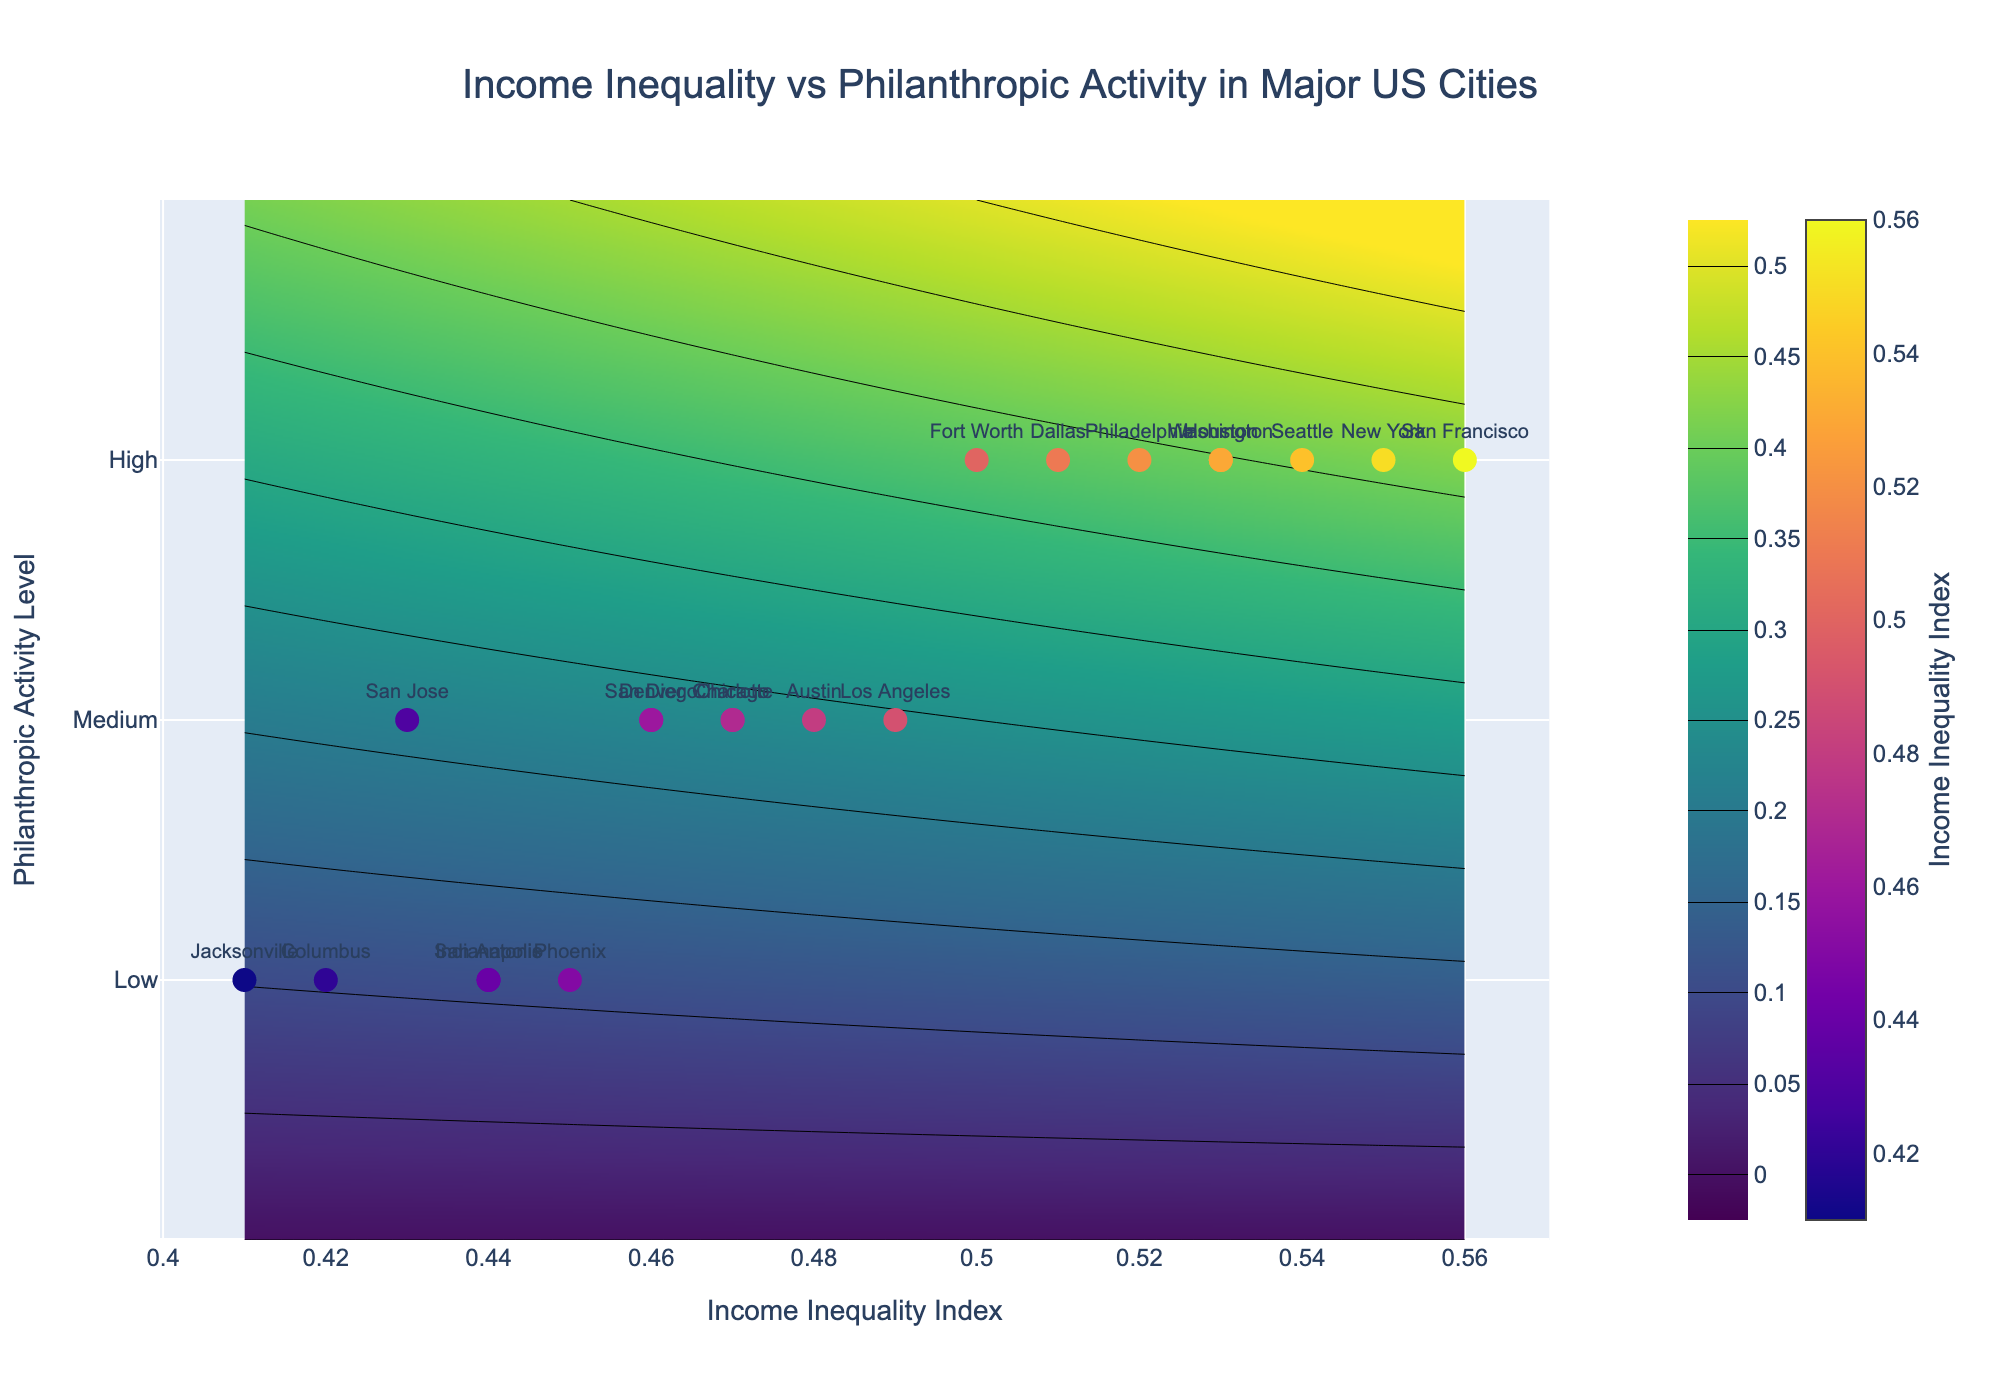What is the title of the figure? The title of the figure is prominently displayed at the top. According to the details provided, the title reads: 'Income Inequality vs Philanthropic Activity in Major US Cities'.
Answer: Income Inequality vs Philanthropic Activity in Major US Cities How many cities in the figure have a high level of philanthropic activity? To find this, we look for the markers positioned at y = 0.75, which represent a high level of philanthropic activity. Counting these markers, we find six cities (New York, Houston, Philadelphia, Dallas, San Francisco, Seattle, and Washington).
Answer: 7 Which city has the highest income inequality index? By examining the x-axis values and looking for the city label with the maximum value on this axis, we find that San Francisco has the highest income inequality index of 0.56.
Answer: San Francisco What is the philanthropic activity level of Phoenix? Locate Phoenix on the contour plot by finding the labeled marker. Noting its y-axis value, it is positioned at 0.25, correlating with a low philanthropic activity level.
Answer: Low Compare the philanthropic activity levels of New York and Los Angeles. New York is positioned at y = 0.75, indicating high philanthropic activity, while Los Angeles is at y = 0.5, indicating medium philanthropic activity. Therefore, New York has a higher philanthropic activity level than Los Angeles.
Answer: New York has a higher level What is the median income inequality index of the cities with medium philanthropic activity? First, identify the cities with medium philanthropic activity (y = 0.5). The cities are Los Angeles, Chicago, San Diego, Austin, Charlotte, Denver, and San Jose. Their income inequality indices are 0.49, 0.47, 0.46, 0.48, 0.47, 0.46, and 0.43 respectively. Arranging them in ascending order: 0.43, 0.46, 0.46, 0.47, 0.47, 0.48, 0.49. The median value, being the middle one in this ordered list, is 0.47.
Answer: 0.47 Which city has a lower income inequality index: Houston or Philadelphia? By examining their positions on the x-axis, Houston has an income inequality index of 0.53, while Philadelphia has 0.52. Therefore, Philadelphia has a slightly lower index.
Answer: Philadelphia For cities with high philanthropic activity, what is the average income inequality index? First, note the cities with high philanthropic activity and their corresponding indices: New York (0.55), Houston (0.53), Philadelphia (0.52), Dallas (0.51), San Francisco (0.56), Seattle (0.54), and Washington (0.53). Summing these values: 0.55 + 0.53 + 0.52 + 0.51 + 0.56 + 0.54 + 0.53 = 3.74. Dividing by the number of cities (7), the average is 3.74 / 7 = 0.534.
Answer: 0.534 How many cities have an income inequality index below 0.45? Identify cities with x-axis values below 0.45. These are San Jose (0.43), Jacksonville (0.41), Columbus (0.42). Counting them, there are three such cities.
Answer: 3 